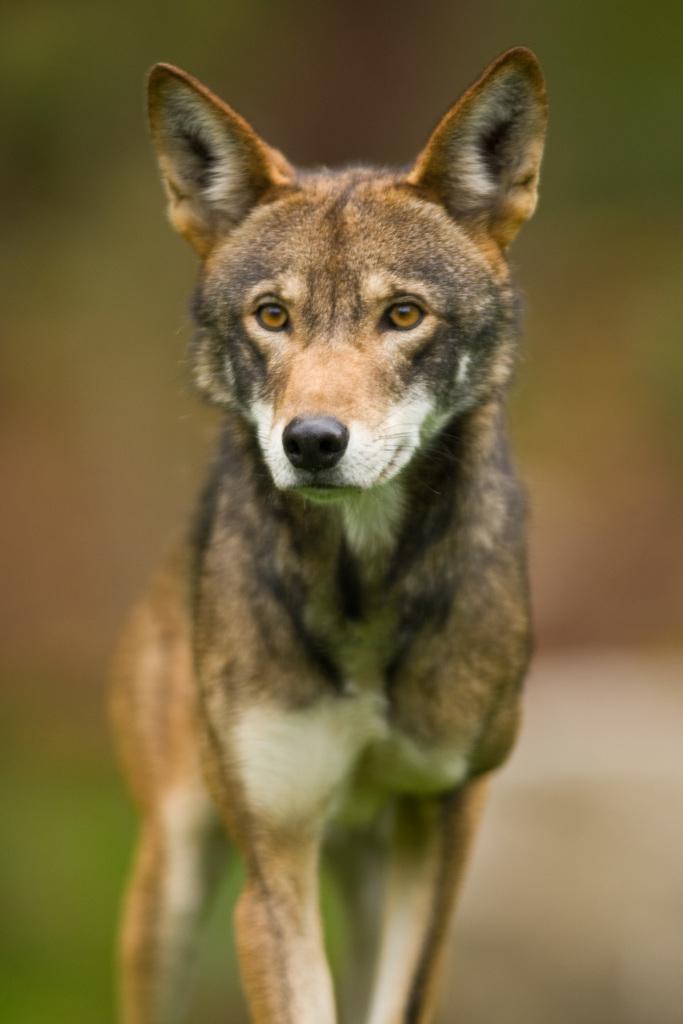Can you describe this image briefly? This image consists of a dog in brown color. The background is blurred. 